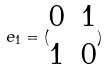Convert formula to latex. <formula><loc_0><loc_0><loc_500><loc_500>e _ { 1 } = ( \begin{matrix} 0 & 1 \\ 1 & 0 \end{matrix} )</formula> 